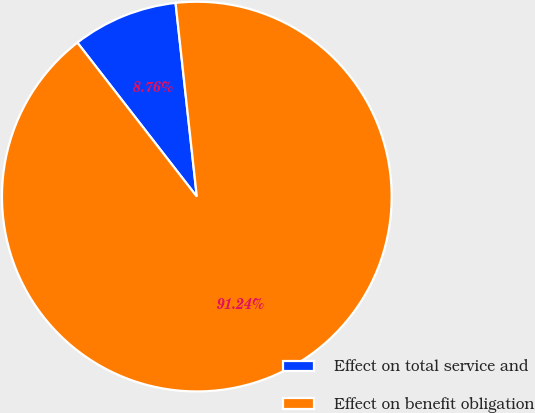Convert chart to OTSL. <chart><loc_0><loc_0><loc_500><loc_500><pie_chart><fcel>Effect on total service and<fcel>Effect on benefit obligation<nl><fcel>8.76%<fcel>91.24%<nl></chart> 